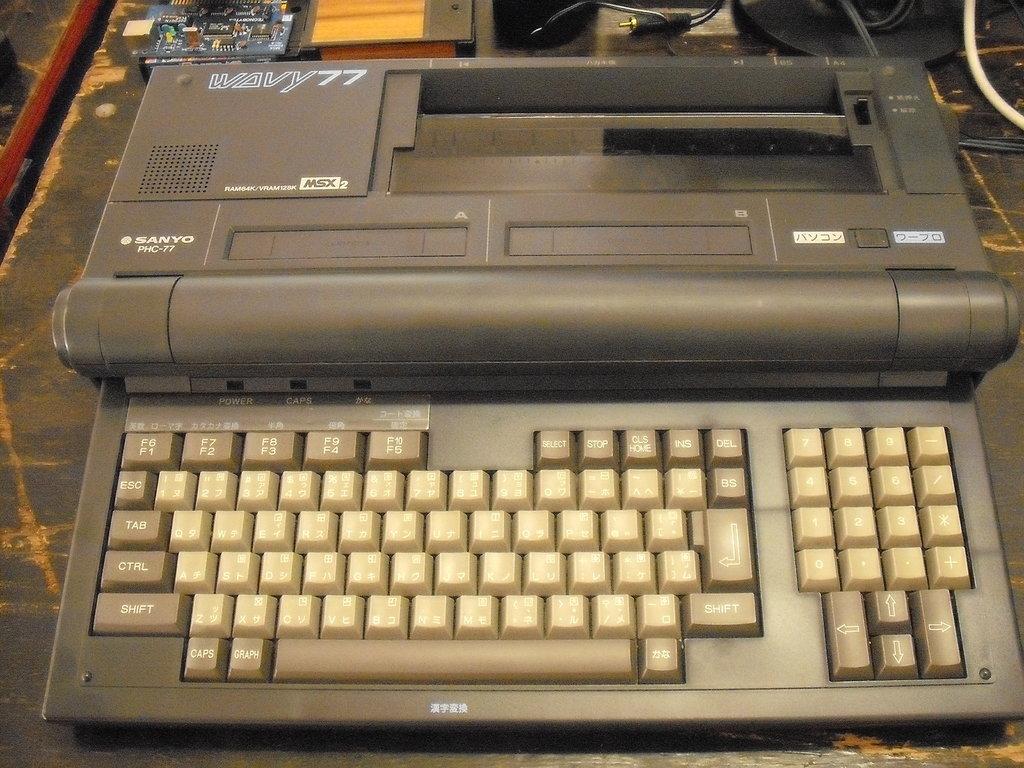What model of typewriter is this?
Make the answer very short. Sanyo. What's the key to the very top left?
Your response must be concise. F6 f1. 